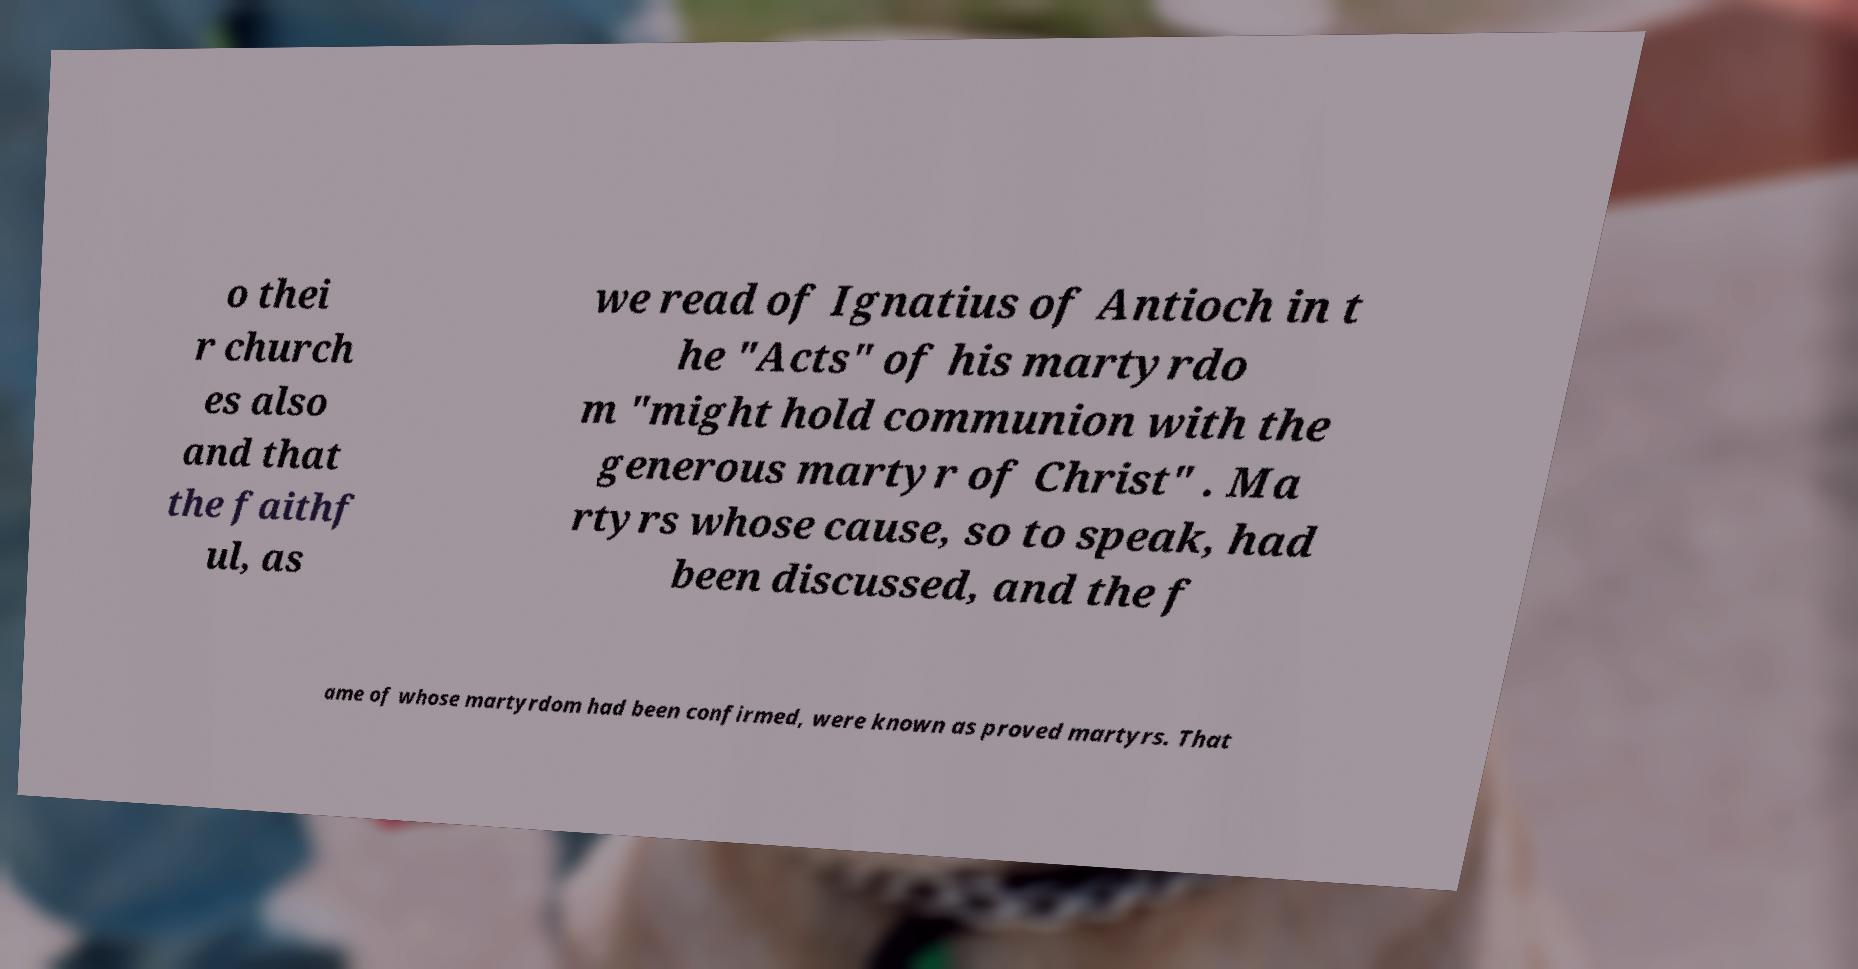Can you accurately transcribe the text from the provided image for me? o thei r church es also and that the faithf ul, as we read of Ignatius of Antioch in t he "Acts" of his martyrdo m "might hold communion with the generous martyr of Christ" . Ma rtyrs whose cause, so to speak, had been discussed, and the f ame of whose martyrdom had been confirmed, were known as proved martyrs. That 